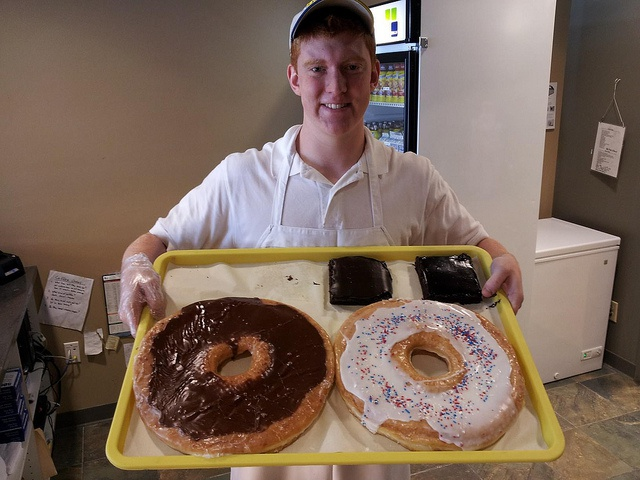Describe the objects in this image and their specific colors. I can see people in brown, gray, darkgray, and lavender tones, refrigerator in brown, darkgray, lightgray, and black tones, donut in brown, black, maroon, and gray tones, donut in brown, darkgray, and gray tones, and refrigerator in brown, darkgray, and gray tones in this image. 